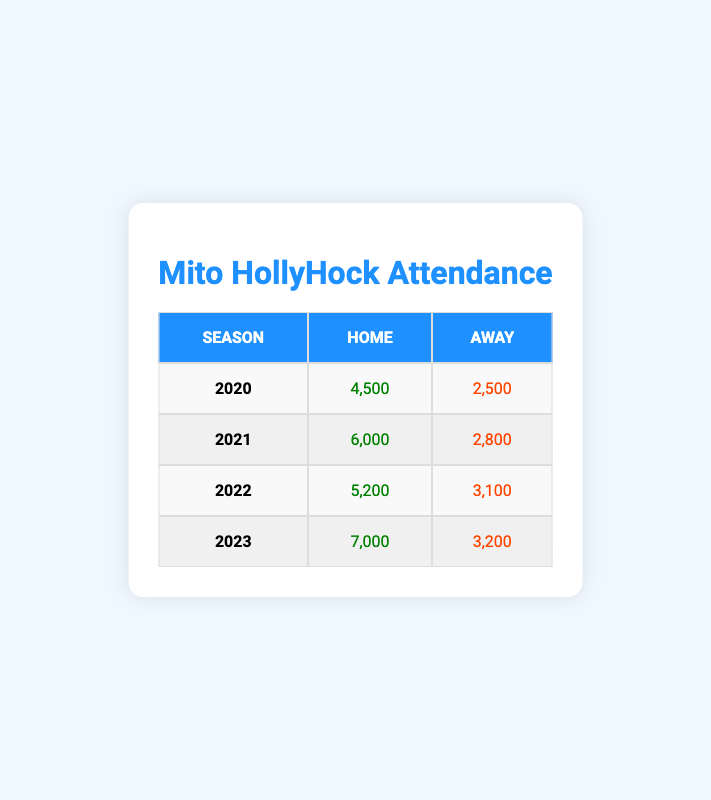What was the attendance for Mito HollyHock's home matches in 2021? The table shows the attendance figures for different match types in various seasons. Looking at the 2021 row under the Home column, the attendance is listed as 6,000.
Answer: 6,000 What is the attendance difference between home and away matches in 2020? For the year 2020, the home attendance is 4,500 and the away attendance is 2,500. The difference is calculated by subtracting the away attendance from the home attendance: 4,500 - 2,500 = 2,000.
Answer: 2,000 Is it true that attendance for away matches was higher in 2022 than in 2021? In 2022, the attendance for away matches is 3,100, while in 2021 it is 2,800. Since 3,100 is greater than 2,800, the statement is true.
Answer: Yes What was the total attendance for home matches from 2020 to 2023? To find the total attendance for home matches, we sum the figures for each year: 4,500 (2020) + 6,000 (2021) + 5,200 (2022) + 7,000 (2023) = 22,700.
Answer: 22,700 What is the highest attendance recorded for away matches across all seasons shown in the table? Looking at the away attendance for each season, we note the figures: 2,500 (2020), 2,800 (2021), 3,100 (2022), and 3,200 (2023). The highest among these values is 3,200 in 2023.
Answer: 3,200 Did Mito HollyHock have more than 5,000 fans on average for home matches over the four recorded seasons? The home attendances are: 4,500 (2020), 6,000 (2021), 5,200 (2022), and 7,000 (2023). The average is calculated as follows: (4,500 + 6,000 + 5,200 + 7,000) / 4 = 5,175. Since 5,175 is greater than 5,000, the answer is yes.
Answer: Yes What was the overall attendance for Mito HollyHock matches (both home and away) in 2023? In 2023, home attendance is 7,000 and away attendance is 3,200. The total attendance is calculated by adding these two figures: 7,000 + 3,200 = 10,200.
Answer: 10,200 Which season had the lowest total attendance when considering both home and away matches? We sum the respective home and away attendances for each season: 2020: 4,500 + 2,500 = 7,000, 2021: 6,000 + 2,800 = 8,800, 2022: 5,200 + 3,100 = 8,300, 2023: 7,000 + 3,200 = 10,200. The lowest total is 7,000 in 2020.
Answer: 2020 